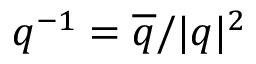Convert formula to latex. <formula><loc_0><loc_0><loc_500><loc_500>q ^ { - 1 } = \overline { q } / | q | ^ { 2 }</formula> 